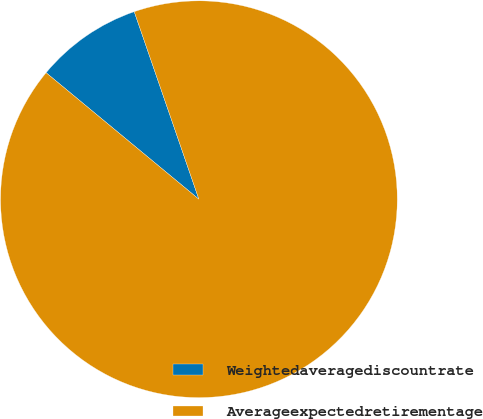<chart> <loc_0><loc_0><loc_500><loc_500><pie_chart><fcel>Weightedaveragediscountrate<fcel>Averageexpectedretirementage<nl><fcel>8.71%<fcel>91.29%<nl></chart> 